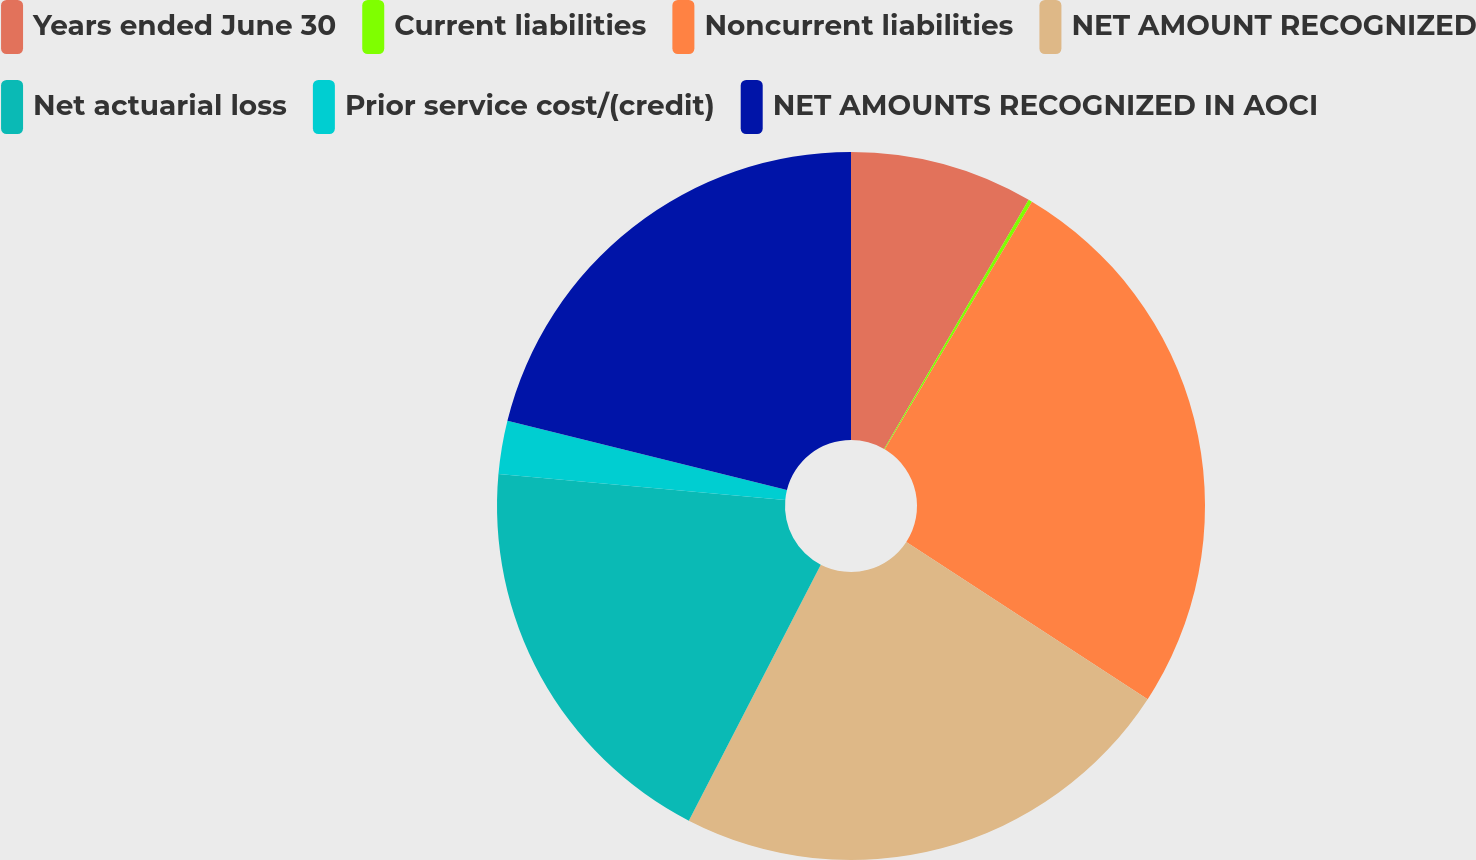<chart> <loc_0><loc_0><loc_500><loc_500><pie_chart><fcel>Years ended June 30<fcel>Current liabilities<fcel>Noncurrent liabilities<fcel>NET AMOUNT RECOGNIZED<fcel>Net actuarial loss<fcel>Prior service cost/(credit)<fcel>NET AMOUNTS RECOGNIZED IN AOCI<nl><fcel>8.37%<fcel>0.17%<fcel>25.65%<fcel>23.39%<fcel>18.87%<fcel>2.43%<fcel>21.13%<nl></chart> 